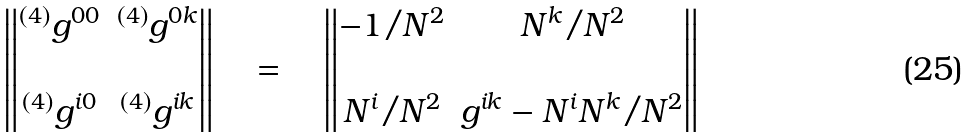Convert formula to latex. <formula><loc_0><loc_0><loc_500><loc_500>\begin{Vmatrix} ^ { ( 4 ) } g ^ { 0 0 } & ^ { ( 4 ) } g ^ { 0 k } \\ \\ ^ { ( 4 ) } g ^ { i 0 } & ^ { ( 4 ) } g ^ { i k } \end{Vmatrix} \quad = \quad \begin{Vmatrix} - 1 / N ^ { 2 } & N ^ { k } / N ^ { 2 } \\ \\ N ^ { i } / N ^ { 2 } & g ^ { i k } - N ^ { i } N ^ { k } / N ^ { 2 } \end{Vmatrix}</formula> 